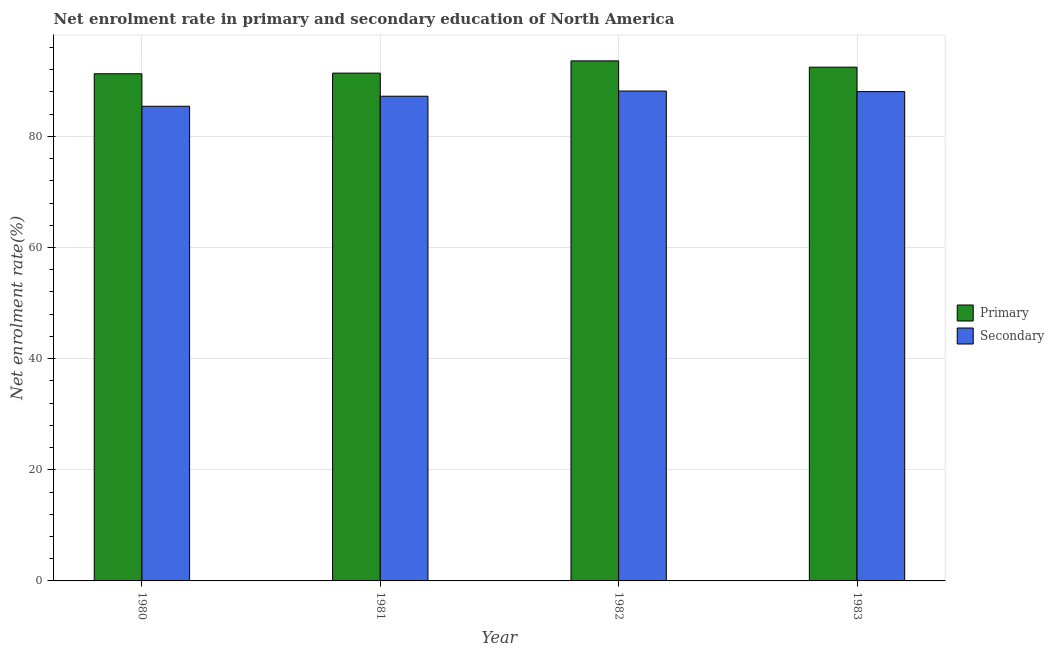How many bars are there on the 3rd tick from the left?
Provide a short and direct response. 2. In how many cases, is the number of bars for a given year not equal to the number of legend labels?
Provide a succinct answer. 0. What is the enrollment rate in primary education in 1980?
Your response must be concise. 91.26. Across all years, what is the maximum enrollment rate in primary education?
Offer a very short reply. 93.58. Across all years, what is the minimum enrollment rate in primary education?
Offer a very short reply. 91.26. In which year was the enrollment rate in primary education minimum?
Your response must be concise. 1980. What is the total enrollment rate in primary education in the graph?
Offer a terse response. 368.68. What is the difference between the enrollment rate in secondary education in 1981 and that in 1982?
Offer a terse response. -0.93. What is the difference between the enrollment rate in primary education in 1982 and the enrollment rate in secondary education in 1983?
Ensure brevity in your answer.  1.13. What is the average enrollment rate in secondary education per year?
Provide a short and direct response. 87.21. In the year 1982, what is the difference between the enrollment rate in secondary education and enrollment rate in primary education?
Offer a very short reply. 0. In how many years, is the enrollment rate in secondary education greater than 12 %?
Offer a terse response. 4. What is the ratio of the enrollment rate in primary education in 1981 to that in 1982?
Provide a short and direct response. 0.98. Is the enrollment rate in primary education in 1980 less than that in 1981?
Keep it short and to the point. Yes. What is the difference between the highest and the second highest enrollment rate in primary education?
Make the answer very short. 1.13. What is the difference between the highest and the lowest enrollment rate in secondary education?
Offer a terse response. 2.74. In how many years, is the enrollment rate in primary education greater than the average enrollment rate in primary education taken over all years?
Offer a very short reply. 2. What does the 2nd bar from the left in 1981 represents?
Keep it short and to the point. Secondary. What does the 2nd bar from the right in 1982 represents?
Offer a terse response. Primary. What is the difference between two consecutive major ticks on the Y-axis?
Give a very brief answer. 20. Are the values on the major ticks of Y-axis written in scientific E-notation?
Provide a short and direct response. No. Does the graph contain any zero values?
Make the answer very short. No. Where does the legend appear in the graph?
Your answer should be very brief. Center right. How many legend labels are there?
Your answer should be very brief. 2. What is the title of the graph?
Give a very brief answer. Net enrolment rate in primary and secondary education of North America. Does "Urban" appear as one of the legend labels in the graph?
Offer a terse response. No. What is the label or title of the X-axis?
Give a very brief answer. Year. What is the label or title of the Y-axis?
Provide a short and direct response. Net enrolment rate(%). What is the Net enrolment rate(%) in Primary in 1980?
Make the answer very short. 91.26. What is the Net enrolment rate(%) of Secondary in 1980?
Provide a short and direct response. 85.42. What is the Net enrolment rate(%) of Primary in 1981?
Make the answer very short. 91.38. What is the Net enrolment rate(%) of Secondary in 1981?
Your answer should be very brief. 87.22. What is the Net enrolment rate(%) of Primary in 1982?
Ensure brevity in your answer.  93.58. What is the Net enrolment rate(%) of Secondary in 1982?
Your response must be concise. 88.15. What is the Net enrolment rate(%) of Primary in 1983?
Your response must be concise. 92.45. What is the Net enrolment rate(%) in Secondary in 1983?
Offer a very short reply. 88.05. Across all years, what is the maximum Net enrolment rate(%) of Primary?
Your response must be concise. 93.58. Across all years, what is the maximum Net enrolment rate(%) of Secondary?
Your response must be concise. 88.15. Across all years, what is the minimum Net enrolment rate(%) in Primary?
Provide a succinct answer. 91.26. Across all years, what is the minimum Net enrolment rate(%) of Secondary?
Ensure brevity in your answer.  85.42. What is the total Net enrolment rate(%) in Primary in the graph?
Your answer should be very brief. 368.68. What is the total Net enrolment rate(%) in Secondary in the graph?
Make the answer very short. 348.84. What is the difference between the Net enrolment rate(%) in Primary in 1980 and that in 1981?
Your answer should be compact. -0.11. What is the difference between the Net enrolment rate(%) in Secondary in 1980 and that in 1981?
Give a very brief answer. -1.8. What is the difference between the Net enrolment rate(%) in Primary in 1980 and that in 1982?
Keep it short and to the point. -2.32. What is the difference between the Net enrolment rate(%) in Secondary in 1980 and that in 1982?
Your answer should be very brief. -2.74. What is the difference between the Net enrolment rate(%) in Primary in 1980 and that in 1983?
Give a very brief answer. -1.19. What is the difference between the Net enrolment rate(%) of Secondary in 1980 and that in 1983?
Offer a terse response. -2.64. What is the difference between the Net enrolment rate(%) of Primary in 1981 and that in 1982?
Make the answer very short. -2.2. What is the difference between the Net enrolment rate(%) in Secondary in 1981 and that in 1982?
Your response must be concise. -0.93. What is the difference between the Net enrolment rate(%) in Primary in 1981 and that in 1983?
Offer a very short reply. -1.07. What is the difference between the Net enrolment rate(%) of Secondary in 1981 and that in 1983?
Provide a succinct answer. -0.83. What is the difference between the Net enrolment rate(%) in Primary in 1982 and that in 1983?
Ensure brevity in your answer.  1.13. What is the difference between the Net enrolment rate(%) of Secondary in 1982 and that in 1983?
Provide a short and direct response. 0.1. What is the difference between the Net enrolment rate(%) of Primary in 1980 and the Net enrolment rate(%) of Secondary in 1981?
Provide a succinct answer. 4.04. What is the difference between the Net enrolment rate(%) of Primary in 1980 and the Net enrolment rate(%) of Secondary in 1982?
Your answer should be compact. 3.11. What is the difference between the Net enrolment rate(%) of Primary in 1980 and the Net enrolment rate(%) of Secondary in 1983?
Give a very brief answer. 3.21. What is the difference between the Net enrolment rate(%) of Primary in 1981 and the Net enrolment rate(%) of Secondary in 1982?
Your response must be concise. 3.22. What is the difference between the Net enrolment rate(%) in Primary in 1981 and the Net enrolment rate(%) in Secondary in 1983?
Your response must be concise. 3.33. What is the difference between the Net enrolment rate(%) in Primary in 1982 and the Net enrolment rate(%) in Secondary in 1983?
Make the answer very short. 5.53. What is the average Net enrolment rate(%) in Primary per year?
Provide a succinct answer. 92.17. What is the average Net enrolment rate(%) of Secondary per year?
Provide a succinct answer. 87.21. In the year 1980, what is the difference between the Net enrolment rate(%) of Primary and Net enrolment rate(%) of Secondary?
Your answer should be very brief. 5.85. In the year 1981, what is the difference between the Net enrolment rate(%) in Primary and Net enrolment rate(%) in Secondary?
Provide a succinct answer. 4.16. In the year 1982, what is the difference between the Net enrolment rate(%) of Primary and Net enrolment rate(%) of Secondary?
Offer a terse response. 5.43. In the year 1983, what is the difference between the Net enrolment rate(%) of Primary and Net enrolment rate(%) of Secondary?
Ensure brevity in your answer.  4.4. What is the ratio of the Net enrolment rate(%) of Primary in 1980 to that in 1981?
Your answer should be very brief. 1. What is the ratio of the Net enrolment rate(%) in Secondary in 1980 to that in 1981?
Give a very brief answer. 0.98. What is the ratio of the Net enrolment rate(%) in Primary in 1980 to that in 1982?
Provide a succinct answer. 0.98. What is the ratio of the Net enrolment rate(%) in Secondary in 1980 to that in 1982?
Give a very brief answer. 0.97. What is the ratio of the Net enrolment rate(%) of Primary in 1980 to that in 1983?
Provide a succinct answer. 0.99. What is the ratio of the Net enrolment rate(%) in Secondary in 1980 to that in 1983?
Offer a terse response. 0.97. What is the ratio of the Net enrolment rate(%) in Primary in 1981 to that in 1982?
Provide a succinct answer. 0.98. What is the ratio of the Net enrolment rate(%) of Secondary in 1981 to that in 1982?
Ensure brevity in your answer.  0.99. What is the ratio of the Net enrolment rate(%) in Primary in 1981 to that in 1983?
Keep it short and to the point. 0.99. What is the ratio of the Net enrolment rate(%) of Secondary in 1981 to that in 1983?
Your response must be concise. 0.99. What is the ratio of the Net enrolment rate(%) of Primary in 1982 to that in 1983?
Keep it short and to the point. 1.01. What is the ratio of the Net enrolment rate(%) in Secondary in 1982 to that in 1983?
Ensure brevity in your answer.  1. What is the difference between the highest and the second highest Net enrolment rate(%) of Primary?
Provide a succinct answer. 1.13. What is the difference between the highest and the second highest Net enrolment rate(%) in Secondary?
Your answer should be compact. 0.1. What is the difference between the highest and the lowest Net enrolment rate(%) in Primary?
Provide a succinct answer. 2.32. What is the difference between the highest and the lowest Net enrolment rate(%) of Secondary?
Give a very brief answer. 2.74. 